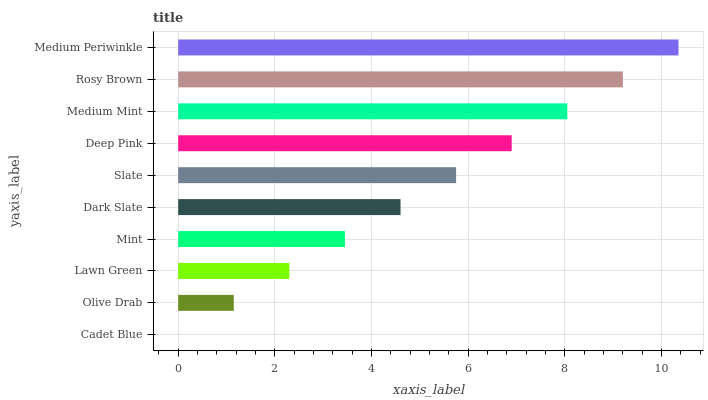Is Cadet Blue the minimum?
Answer yes or no. Yes. Is Medium Periwinkle the maximum?
Answer yes or no. Yes. Is Olive Drab the minimum?
Answer yes or no. No. Is Olive Drab the maximum?
Answer yes or no. No. Is Olive Drab greater than Cadet Blue?
Answer yes or no. Yes. Is Cadet Blue less than Olive Drab?
Answer yes or no. Yes. Is Cadet Blue greater than Olive Drab?
Answer yes or no. No. Is Olive Drab less than Cadet Blue?
Answer yes or no. No. Is Slate the high median?
Answer yes or no. Yes. Is Dark Slate the low median?
Answer yes or no. Yes. Is Olive Drab the high median?
Answer yes or no. No. Is Mint the low median?
Answer yes or no. No. 